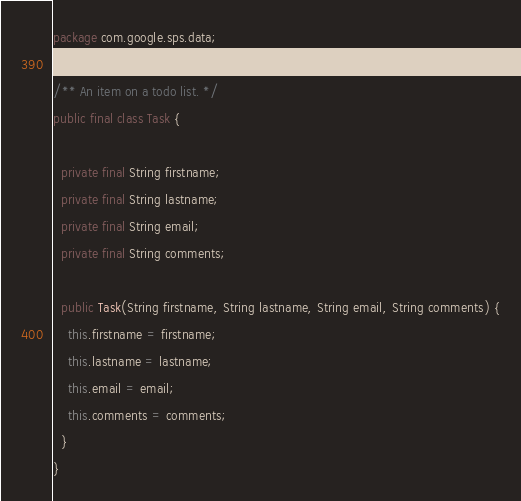<code> <loc_0><loc_0><loc_500><loc_500><_Java_>package com.google.sps.data;

/** An item on a todo list. */
public final class Task {

  private final String firstname;
  private final String lastname;
  private final String email;
  private final String comments;

  public Task(String firstname, String lastname, String email, String comments) {
    this.firstname = firstname;
    this.lastname = lastname;
    this.email = email;
    this.comments = comments;
  }
}</code> 